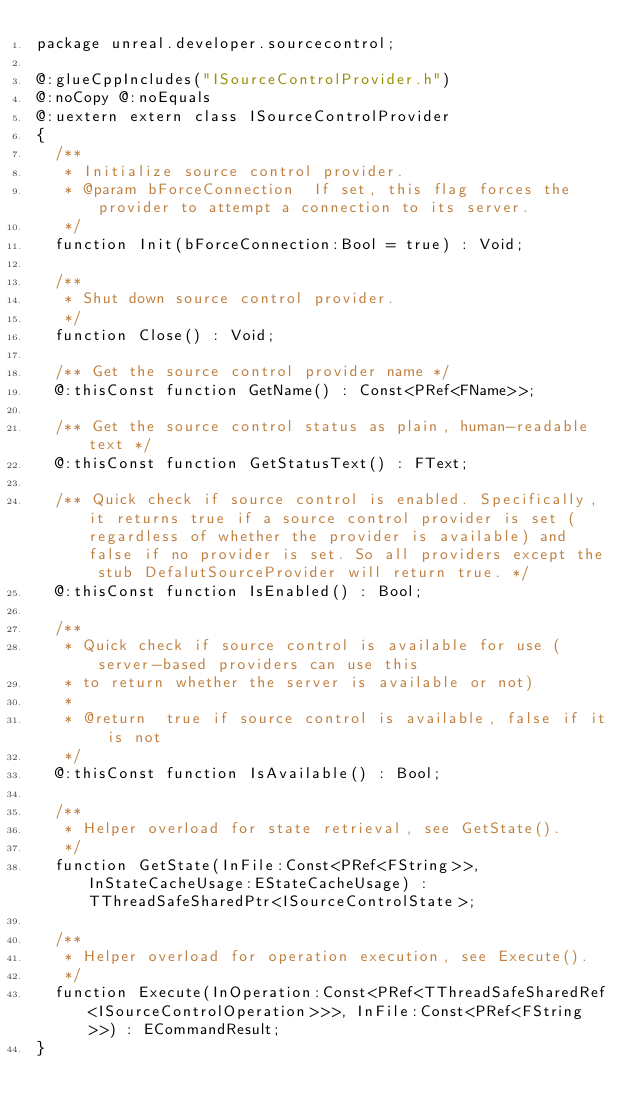<code> <loc_0><loc_0><loc_500><loc_500><_Haxe_>package unreal.developer.sourcecontrol;

@:glueCppIncludes("ISourceControlProvider.h")
@:noCopy @:noEquals
@:uextern extern class ISourceControlProvider
{
	/**
	 * Initialize source control provider.
	 * @param	bForceConnection	If set, this flag forces the provider to attempt a connection to its server.
	 */
	function Init(bForceConnection:Bool = true) : Void;

	/**
	 * Shut down source control provider.
	 */
	function Close() : Void;

	/** Get the source control provider name */
	@:thisConst function GetName() : Const<PRef<FName>>;

	/** Get the source control status as plain, human-readable text */
	@:thisConst function GetStatusText() : FText;

	/** Quick check if source control is enabled. Specifically, it returns true if a source control provider is set (regardless of whether the provider is available) and false if no provider is set. So all providers except the stub DefalutSourceProvider will return true. */
	@:thisConst function IsEnabled() : Bool;

	/**
	 * Quick check if source control is available for use (server-based providers can use this
	 * to return whether the server is available or not)
	 *
	 * @return	true if source control is available, false if it is not
	 */
	@:thisConst function IsAvailable() : Bool;

	/**
	 * Helper overload for state retrieval, see GetState().
	 */
	function GetState(InFile:Const<PRef<FString>>, InStateCacheUsage:EStateCacheUsage) : TThreadSafeSharedPtr<ISourceControlState>;

	/**
	 * Helper overload for operation execution, see Execute().
	 */
	function Execute(InOperation:Const<PRef<TThreadSafeSharedRef<ISourceControlOperation>>>, InFile:Const<PRef<FString>>) : ECommandResult;
}
</code> 